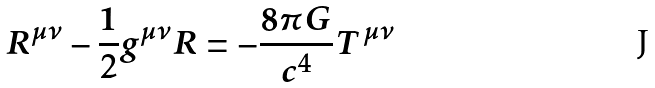Convert formula to latex. <formula><loc_0><loc_0><loc_500><loc_500>R ^ { \mu \nu } - \frac { 1 } { 2 } g ^ { \mu \nu } R = - \frac { 8 \pi G } { c ^ { 4 } } T ^ { \mu \nu }</formula> 